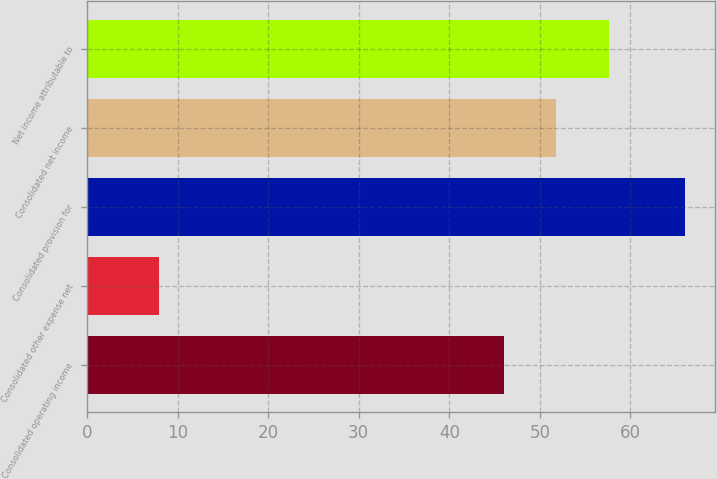Convert chart. <chart><loc_0><loc_0><loc_500><loc_500><bar_chart><fcel>Consolidated operating income<fcel>Consolidated other expense net<fcel>Consolidated provision for<fcel>Consolidated net income<fcel>Net income attributable to<nl><fcel>46<fcel>8<fcel>66<fcel>51.8<fcel>57.6<nl></chart> 